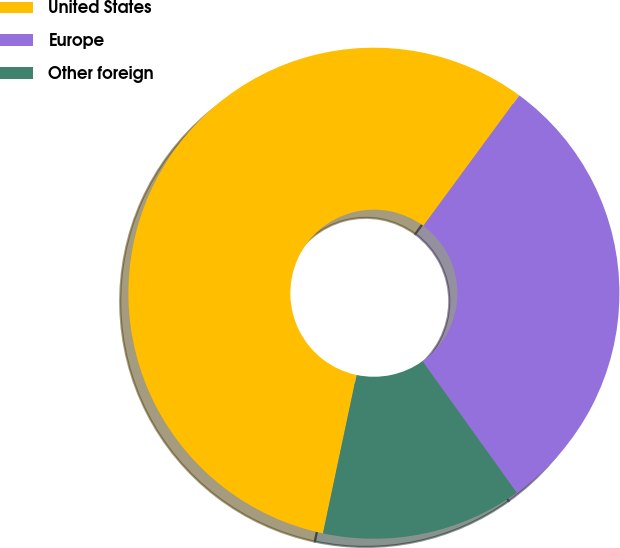Convert chart. <chart><loc_0><loc_0><loc_500><loc_500><pie_chart><fcel>United States<fcel>Europe<fcel>Other foreign<nl><fcel>56.76%<fcel>30.02%<fcel>13.22%<nl></chart> 